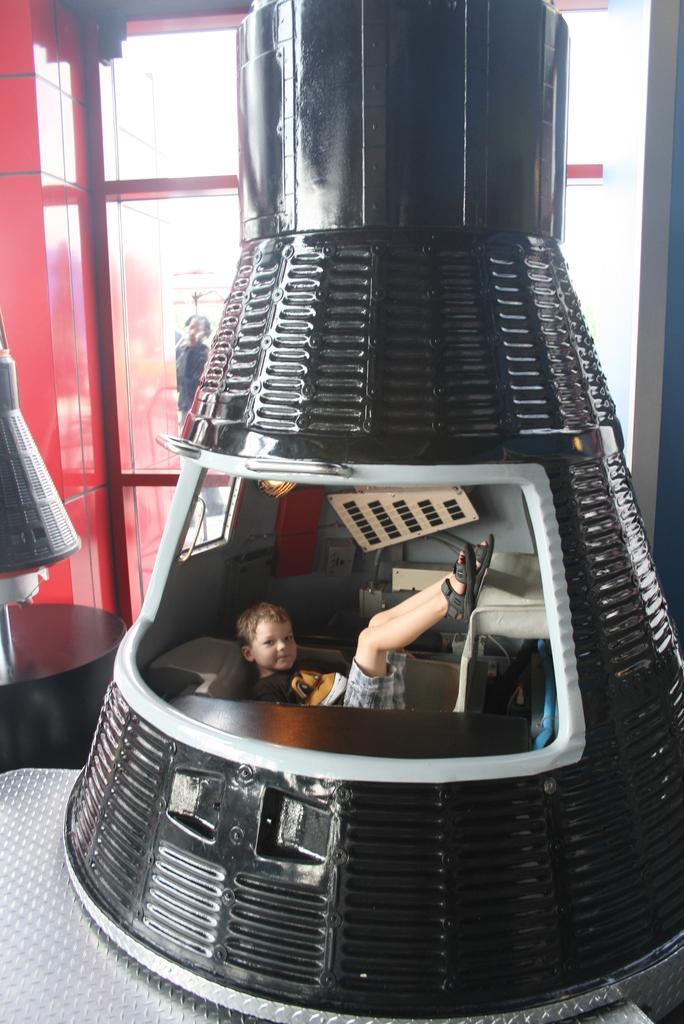Can you describe this image briefly? The image is taken in a room. In the center of the picture there is a bulb like object, in the center of the picture there is a person in it lying. On the left there is a window, outside the window we can see a person. 